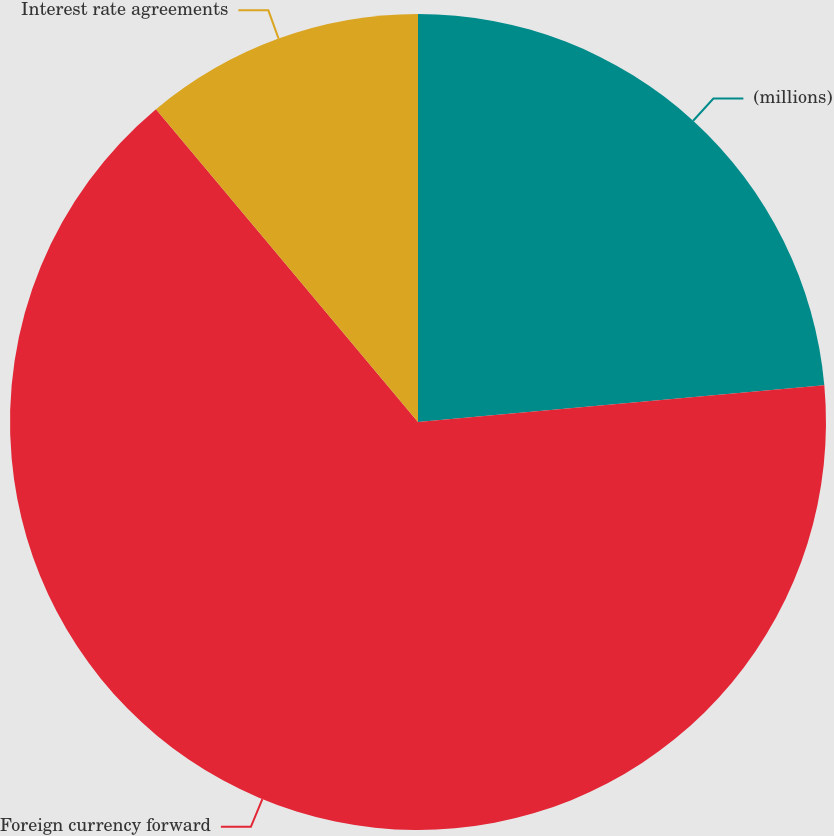Convert chart to OTSL. <chart><loc_0><loc_0><loc_500><loc_500><pie_chart><fcel>(millions)<fcel>Foreign currency forward<fcel>Interest rate agreements<nl><fcel>23.56%<fcel>65.34%<fcel>11.1%<nl></chart> 